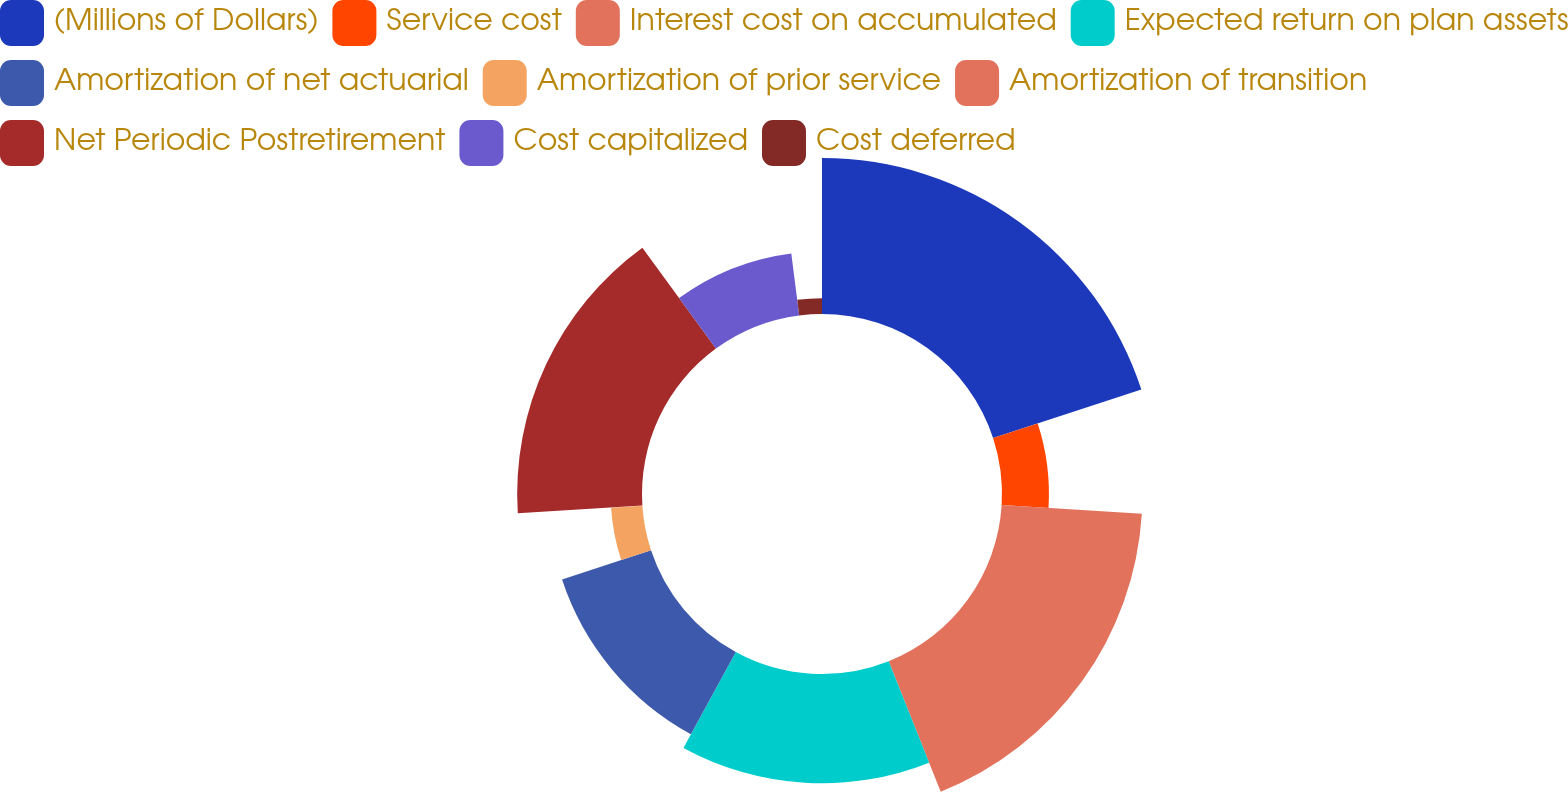Convert chart to OTSL. <chart><loc_0><loc_0><loc_500><loc_500><pie_chart><fcel>(Millions of Dollars)<fcel>Service cost<fcel>Interest cost on accumulated<fcel>Expected return on plan assets<fcel>Amortization of net actuarial<fcel>Amortization of prior service<fcel>Amortization of transition<fcel>Net Periodic Postretirement<fcel>Cost capitalized<fcel>Cost deferred<nl><fcel>19.97%<fcel>6.01%<fcel>17.98%<fcel>13.99%<fcel>11.99%<fcel>4.02%<fcel>0.03%<fcel>15.98%<fcel>8.01%<fcel>2.02%<nl></chart> 